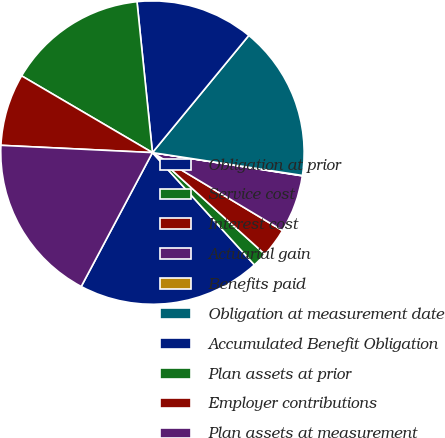Convert chart to OTSL. <chart><loc_0><loc_0><loc_500><loc_500><pie_chart><fcel>Obligation at prior<fcel>Service cost<fcel>Interest cost<fcel>Actuarial gain<fcel>Benefits paid<fcel>Obligation at measurement date<fcel>Accumulated Benefit Obligation<fcel>Plan assets at prior<fcel>Employer contributions<fcel>Plan assets at measurement<nl><fcel>19.51%<fcel>1.57%<fcel>3.1%<fcel>6.15%<fcel>0.04%<fcel>16.45%<fcel>12.58%<fcel>14.93%<fcel>7.68%<fcel>17.98%<nl></chart> 